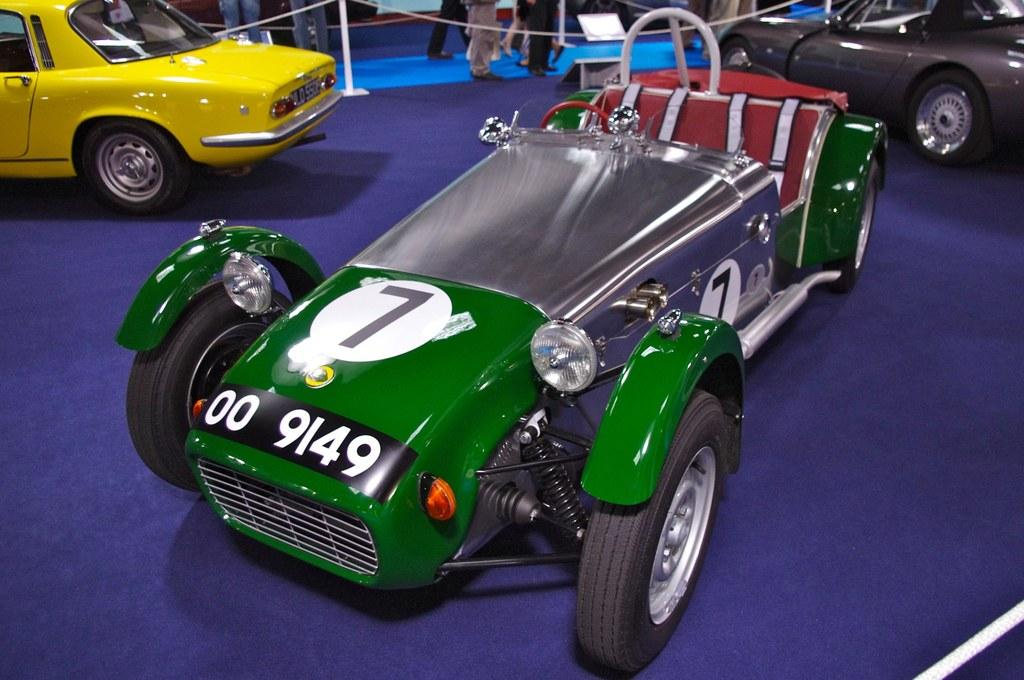Who or what can be seen in the image? There are people in the image. What else is present in the image besides people? There are vehicles, poles with ropes, and a board in the image. What is the ground like in the image? The ground is visible in the image. How many clocks are hanging on the board in the image? There are no clocks present in the image. What type of machine is being used by the people in the image? There is no machine being used by the people in the image. 